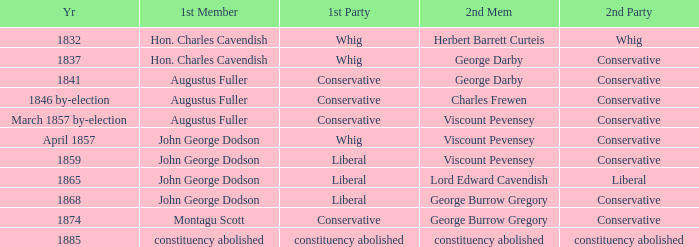In 1865, what was the first party? Liberal. Parse the table in full. {'header': ['Yr', '1st Member', '1st Party', '2nd Mem', '2nd Party'], 'rows': [['1832', 'Hon. Charles Cavendish', 'Whig', 'Herbert Barrett Curteis', 'Whig'], ['1837', 'Hon. Charles Cavendish', 'Whig', 'George Darby', 'Conservative'], ['1841', 'Augustus Fuller', 'Conservative', 'George Darby', 'Conservative'], ['1846 by-election', 'Augustus Fuller', 'Conservative', 'Charles Frewen', 'Conservative'], ['March 1857 by-election', 'Augustus Fuller', 'Conservative', 'Viscount Pevensey', 'Conservative'], ['April 1857', 'John George Dodson', 'Whig', 'Viscount Pevensey', 'Conservative'], ['1859', 'John George Dodson', 'Liberal', 'Viscount Pevensey', 'Conservative'], ['1865', 'John George Dodson', 'Liberal', 'Lord Edward Cavendish', 'Liberal'], ['1868', 'John George Dodson', 'Liberal', 'George Burrow Gregory', 'Conservative'], ['1874', 'Montagu Scott', 'Conservative', 'George Burrow Gregory', 'Conservative'], ['1885', 'constituency abolished', 'constituency abolished', 'constituency abolished', 'constituency abolished']]} 